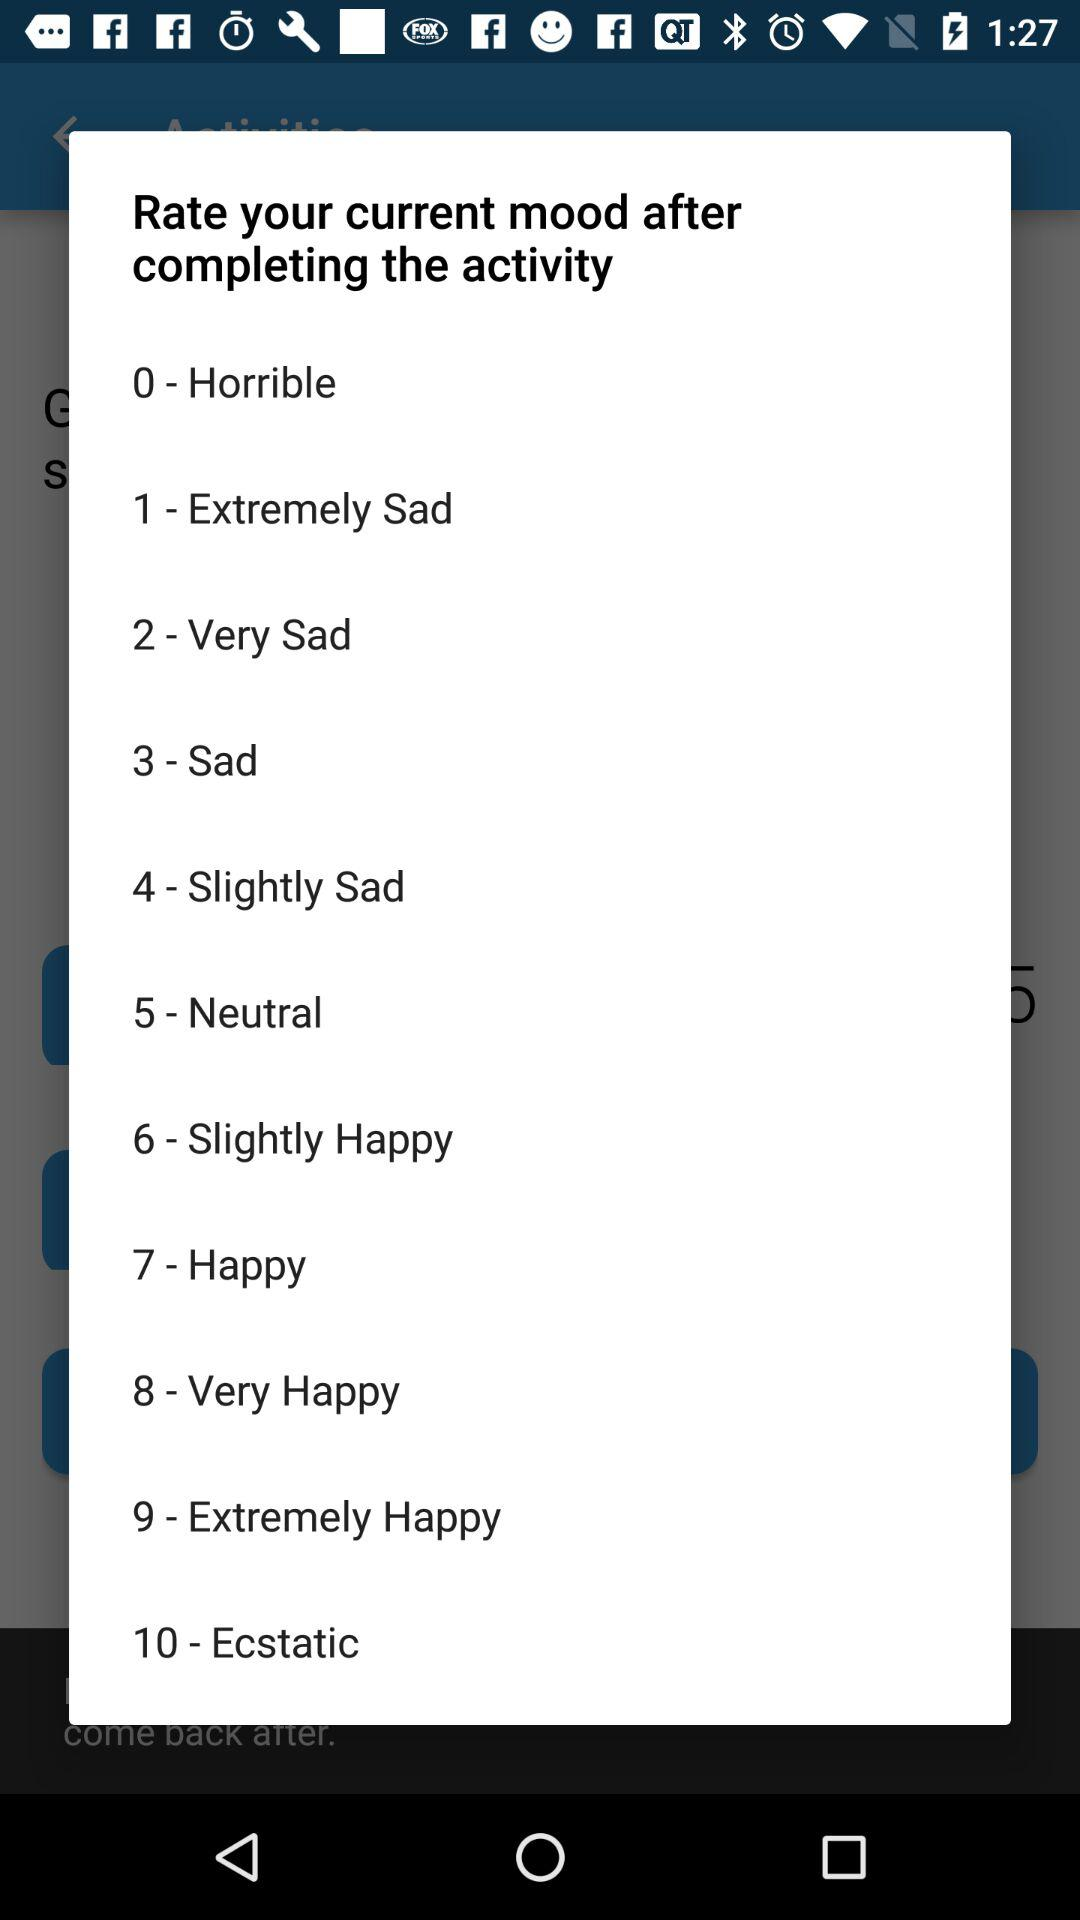How many options are there to rate my current mood?
Answer the question using a single word or phrase. 10 